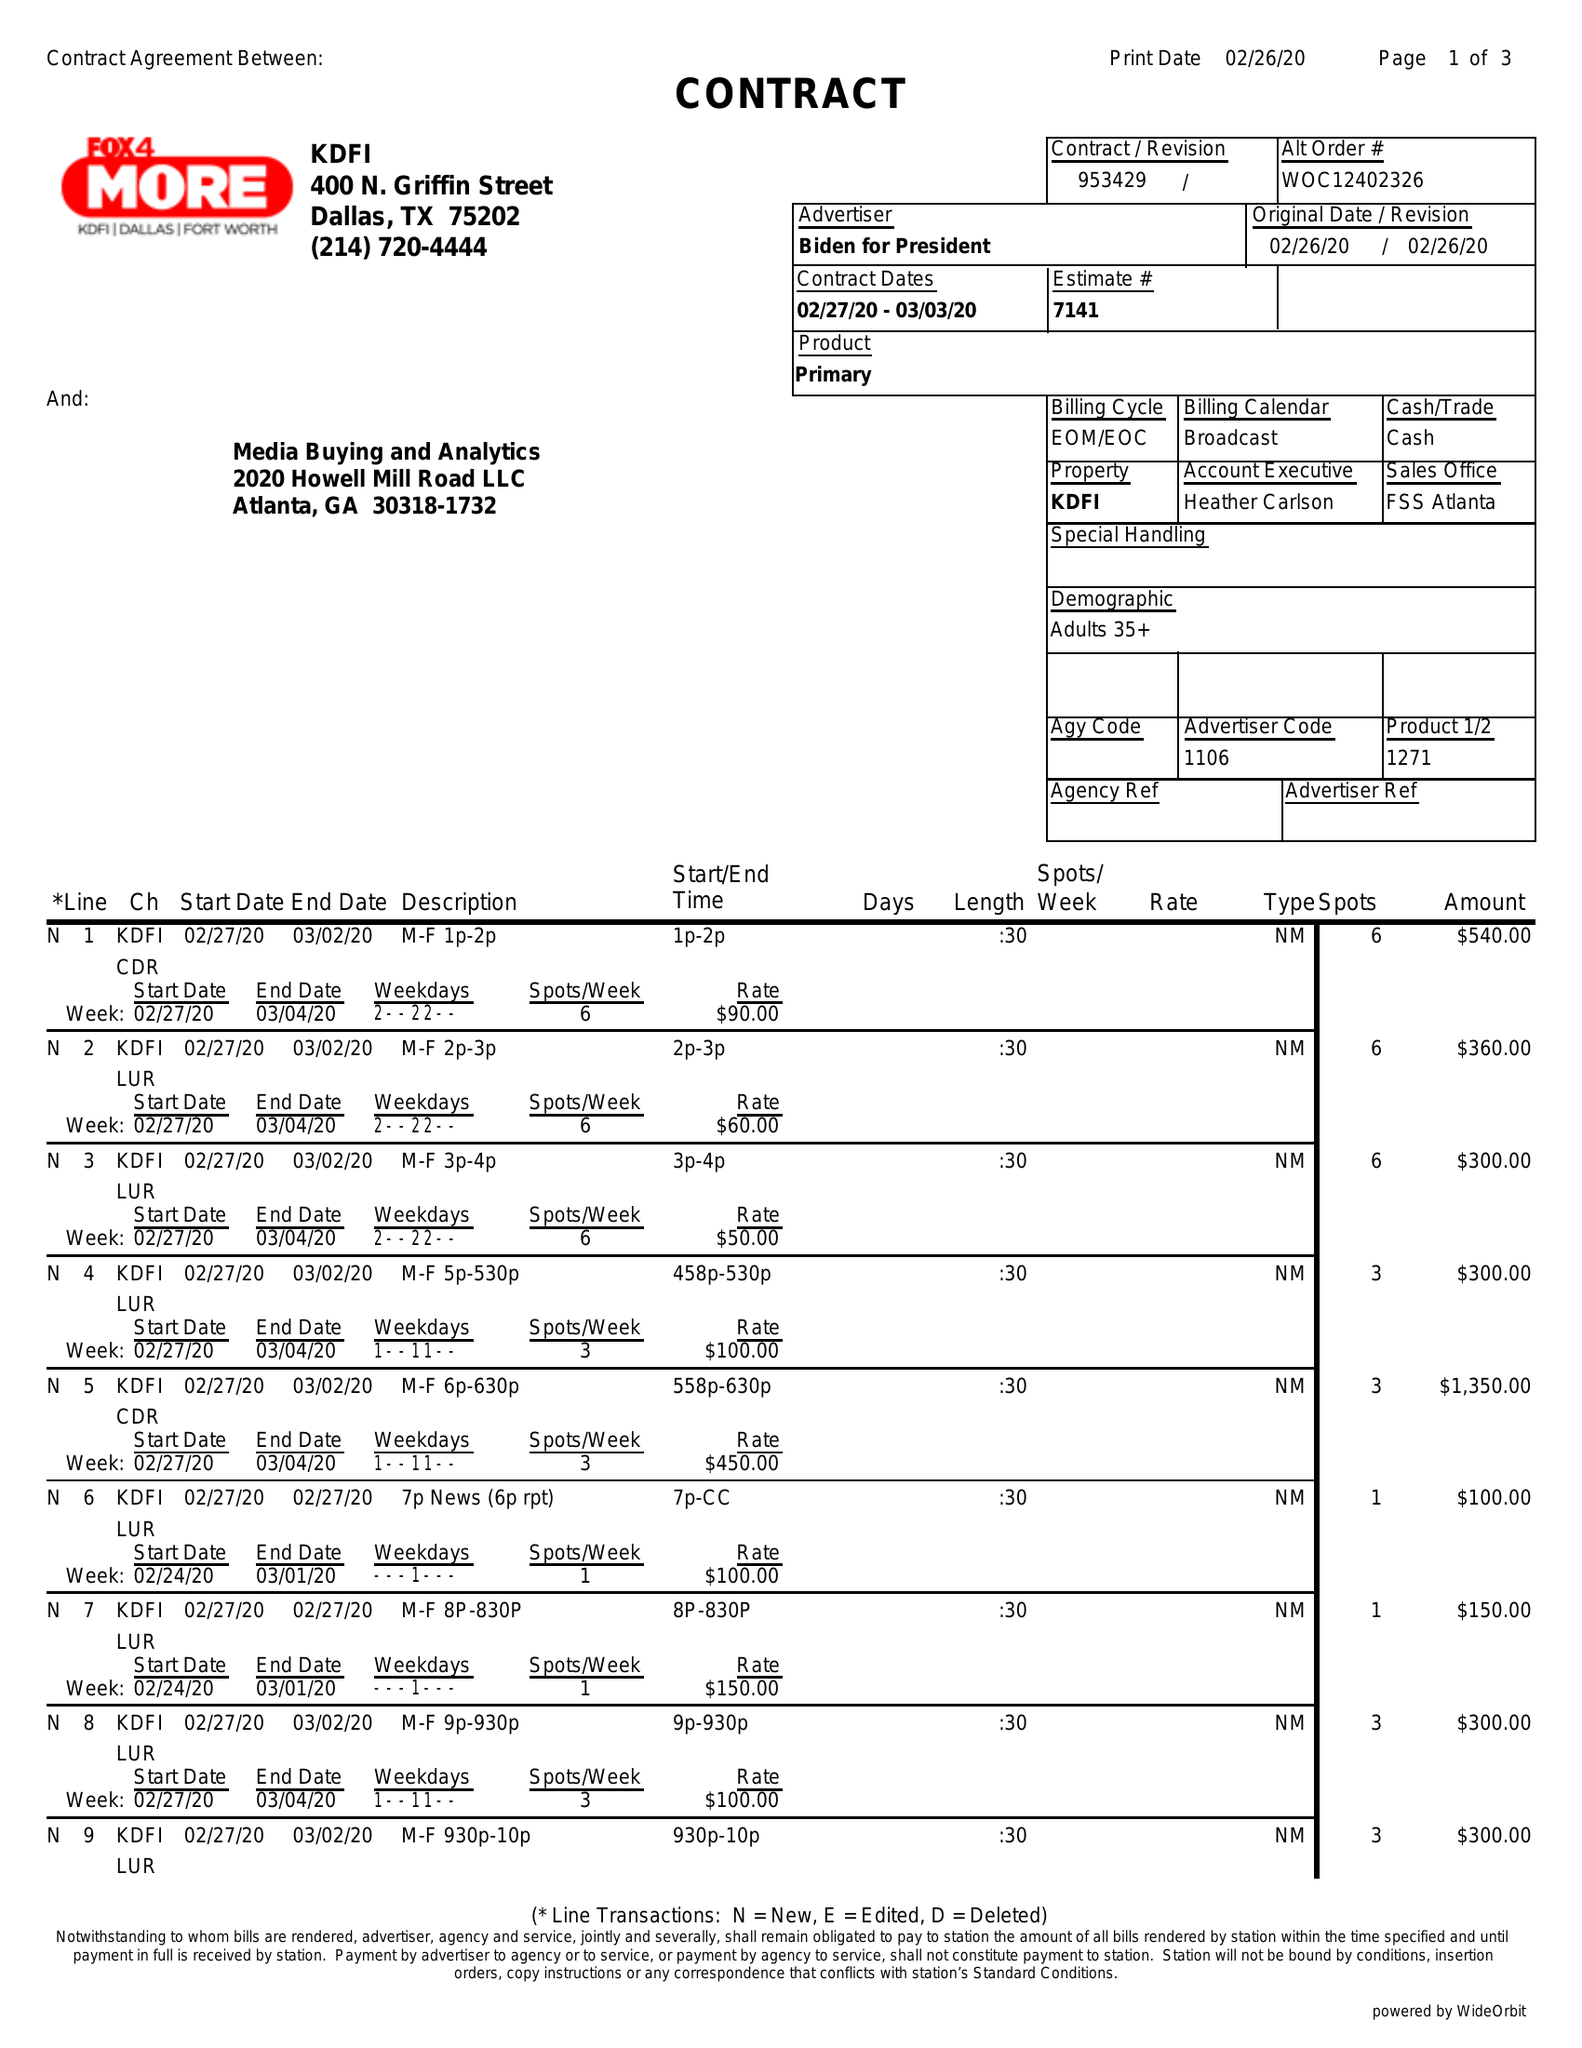What is the value for the flight_from?
Answer the question using a single word or phrase. 02/26/20 